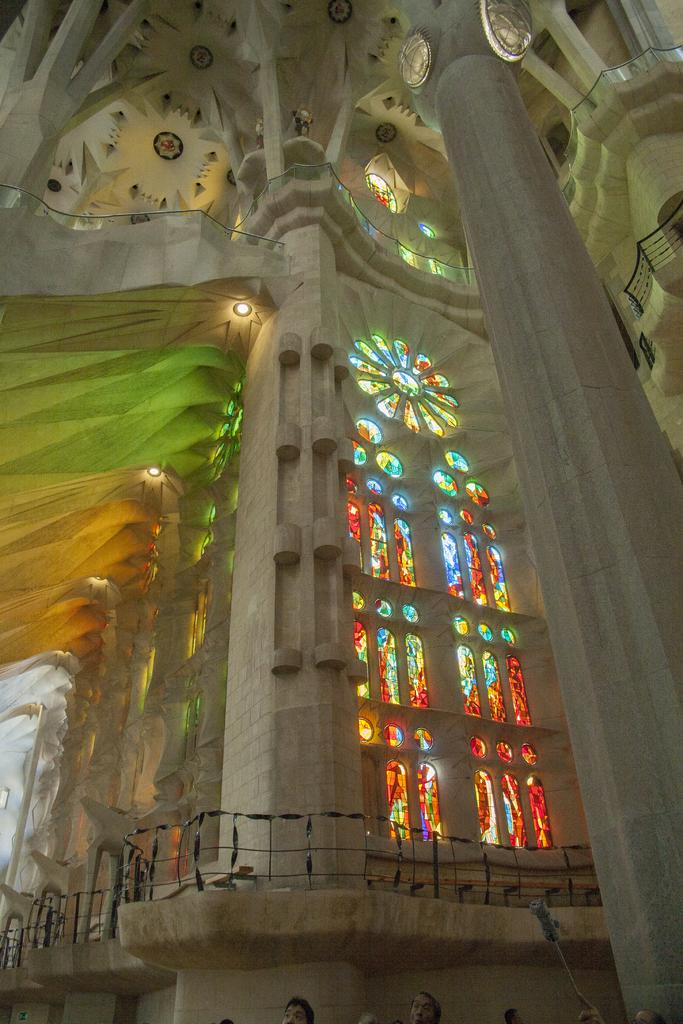What type of location is depicted in the image? The image shows an inside view of a building. Can you describe the lighting in the image? There is light visible in the image. What type of barrier can be seen in the image? There is a fence in the image. What is the color and type of structure present in the image? There is a white color pillar in the image. What other objects can be seen in the image? There are other objects present in the image. What is the price of the house in the image? There is no house present in the image, and therefore no price can be determined. What causes the burst in the image? There is no burst or any indication of damage in the image. 